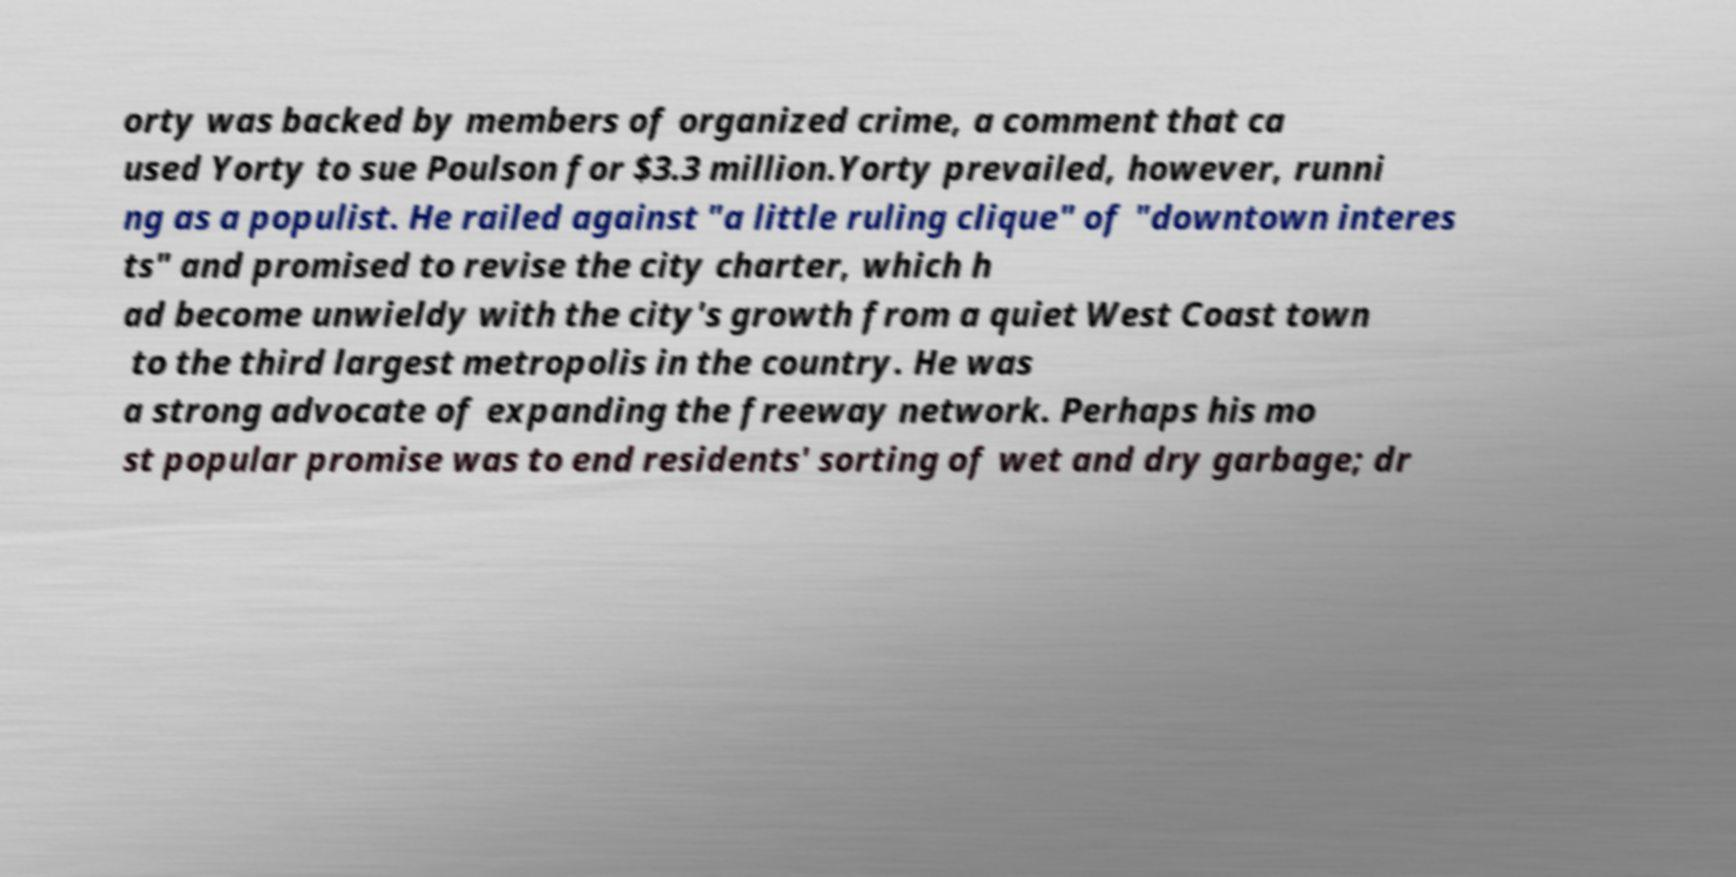Can you read and provide the text displayed in the image?This photo seems to have some interesting text. Can you extract and type it out for me? orty was backed by members of organized crime, a comment that ca used Yorty to sue Poulson for $3.3 million.Yorty prevailed, however, runni ng as a populist. He railed against "a little ruling clique" of "downtown interes ts" and promised to revise the city charter, which h ad become unwieldy with the city's growth from a quiet West Coast town to the third largest metropolis in the country. He was a strong advocate of expanding the freeway network. Perhaps his mo st popular promise was to end residents' sorting of wet and dry garbage; dr 